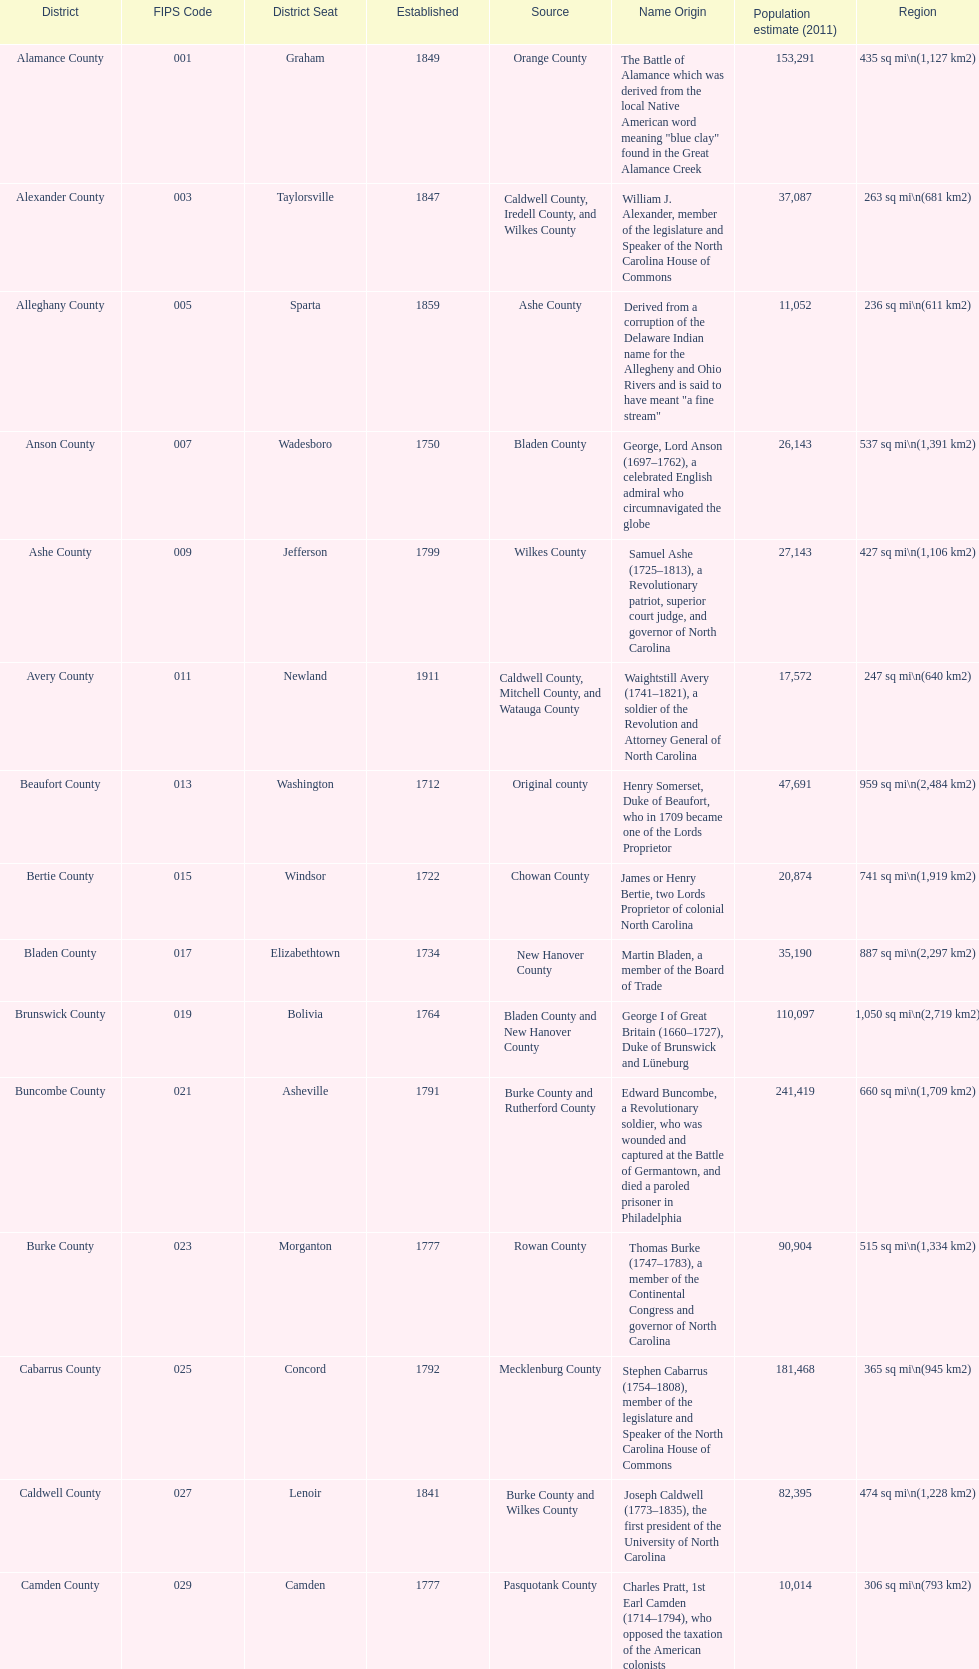Which county has a higher population, alamance or alexander? Alamance County. 